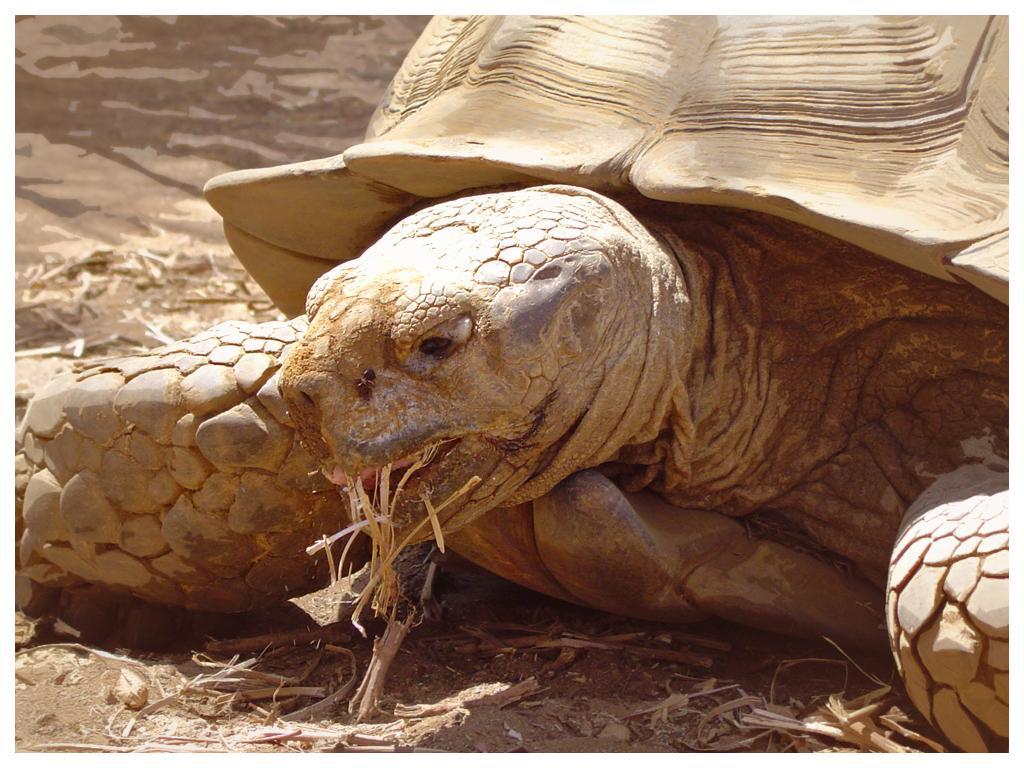In one or two sentences, can you explain what this image depicts? In this image I can see a tortoise on the ground. This image is taken may be during a day near the sandy beach. 